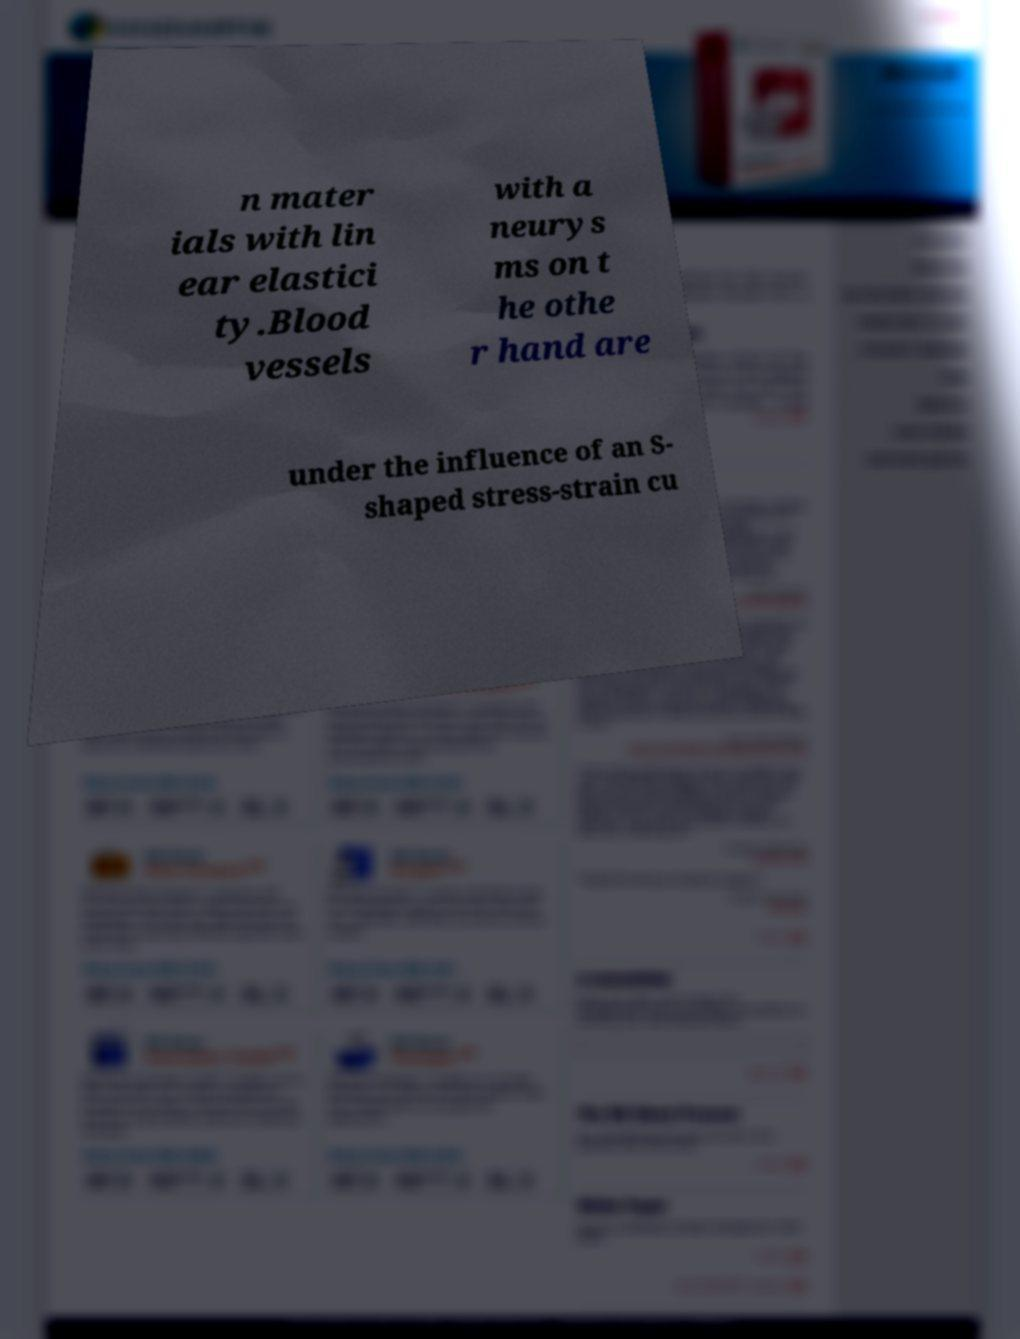Please identify and transcribe the text found in this image. n mater ials with lin ear elastici ty.Blood vessels with a neurys ms on t he othe r hand are under the influence of an S- shaped stress-strain cu 